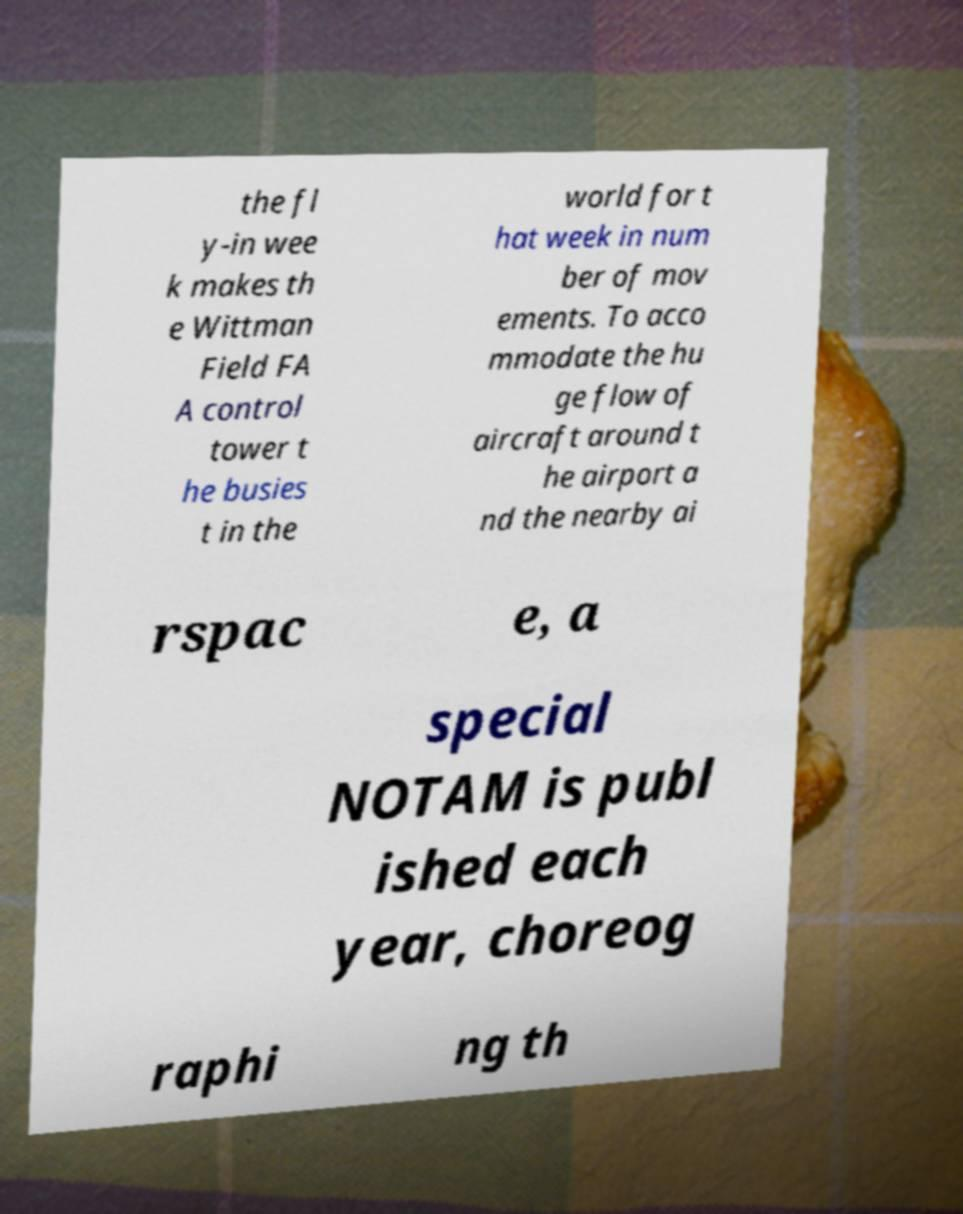Could you assist in decoding the text presented in this image and type it out clearly? the fl y-in wee k makes th e Wittman Field FA A control tower t he busies t in the world for t hat week in num ber of mov ements. To acco mmodate the hu ge flow of aircraft around t he airport a nd the nearby ai rspac e, a special NOTAM is publ ished each year, choreog raphi ng th 